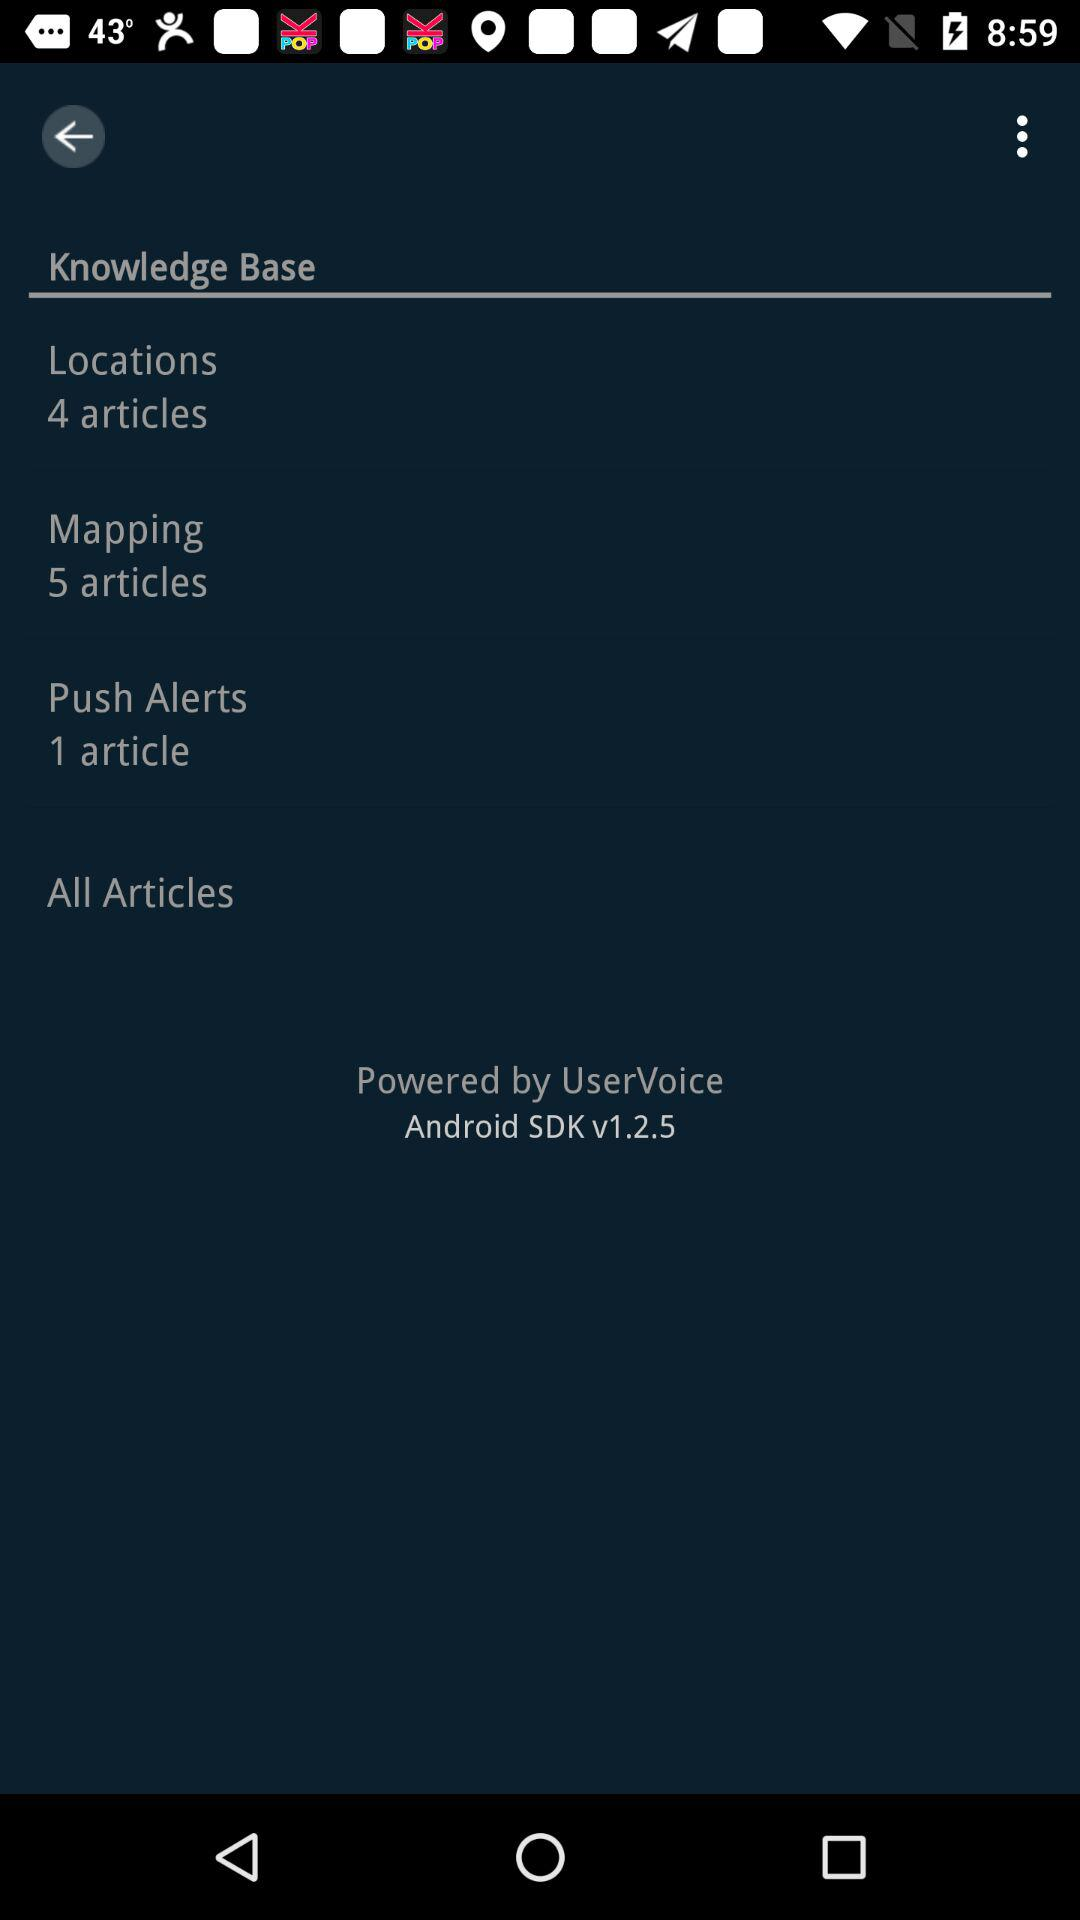How many articles are there in "Locations"? There are 4 articles. 